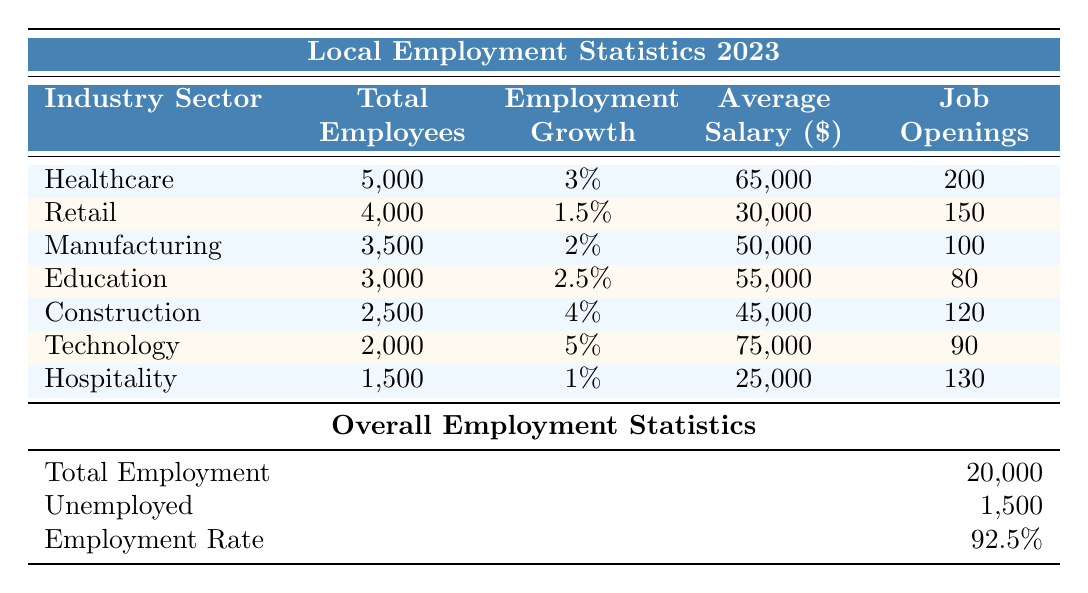What is the total number of employees in the Healthcare sector? The table shows that the total number of employees in the Healthcare sector is directly stated as 5,000.
Answer: 5,000 What percentage of total employment does the Retail sector represent? To find the percentage of total employment represented by the Retail sector, divide the total employees in Retail (4,000) by the total employment (20,000) and multiply by 100: (4,000/20,000) * 100 = 20%.
Answer: 20% Is the average salary in the Technology sector higher than in Manufacturing? The average salary in the Technology sector is 75,000, while in Manufacturing, it is 50,000. Since 75,000 is greater than 50,000, the statement is true.
Answer: Yes How many job openings are there in total across all industry sectors? To find the total job openings, sum the job openings across all sectors: 200 (Healthcare) + 150 (Retail) + 100 (Manufacturing) + 80 (Education) + 120 (Construction) + 90 (Technology) + 130 (Hospitality) = 970 total job openings.
Answer: 970 Which sector has the highest employment growth rate and what is that rate? The Technology sector shows the highest employment growth at 5%, which can be directly seen in the table.
Answer: Technology, 5% If we compare the average salaries of Healthcare and Education sectors, how much higher is the Healthcare average salary? The average salary in Healthcare is 65,000 and in Education it is 55,000. To find the difference, subtract the Education salary from Healthcare: 65,000 - 55,000 = 10,000.
Answer: 10,000 Are there more job openings in Healthcare than in Education? The table shows that Healthcare has 200 job openings while Education has 80. Since 200 is greater than 80, the statement is true.
Answer: Yes What is the average employment growth across all sectors? To find the average employment growth, add the growth percentages of all sectors: 3% (Healthcare) + 1.5% (Retail) + 2% (Manufacturing) + 2.5% (Education) + 4% (Construction) + 5% (Technology) + 1% (Hospitality) = 19%. Divide by 7 sectors: 19% / 7 = approximately 2.71%.
Answer: 2.71% 